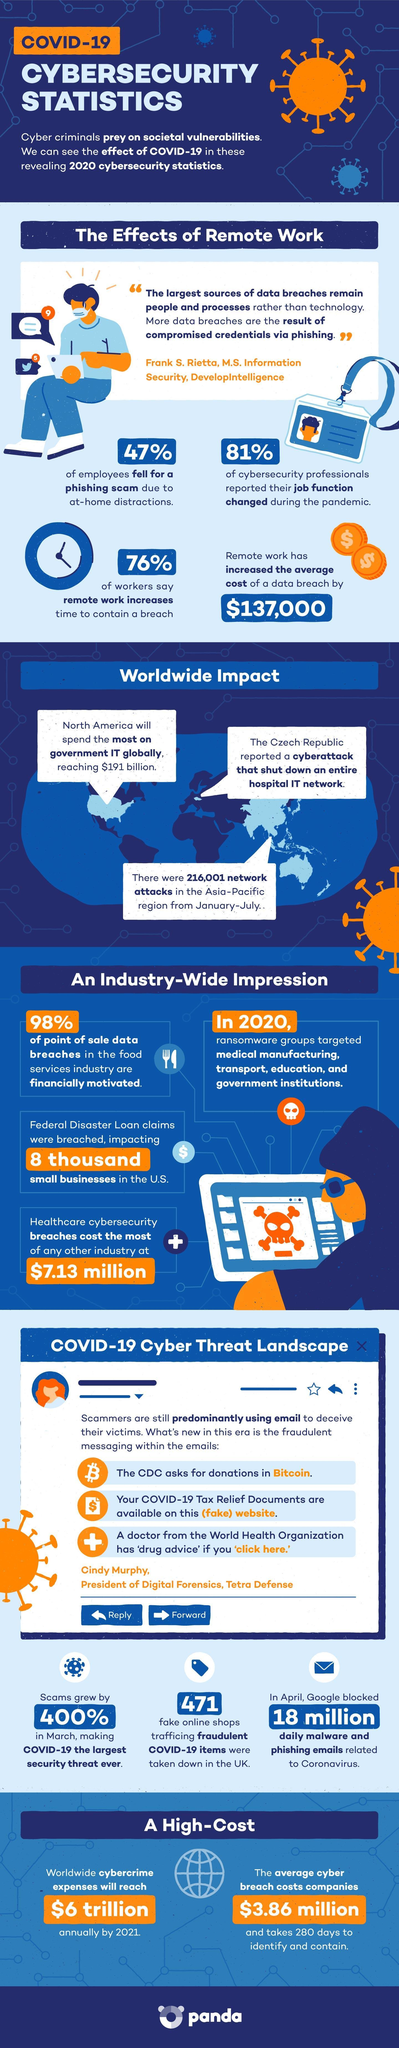What is the number of malware and phishing emails blocked by google in April?
Answer the question with a short phrase. 18 million What percentage of employees fell for a phishing scam? 47% What percentage of scams grew in march? 400% 